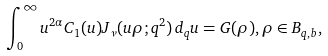Convert formula to latex. <formula><loc_0><loc_0><loc_500><loc_500>\int _ { 0 } ^ { \infty } u ^ { 2 \alpha } C _ { 1 } ( u ) J _ { \nu } ( u \rho ; q ^ { 2 } ) \, d _ { q } u = G ( \rho ) , \rho \in B _ { q , b } ,</formula> 